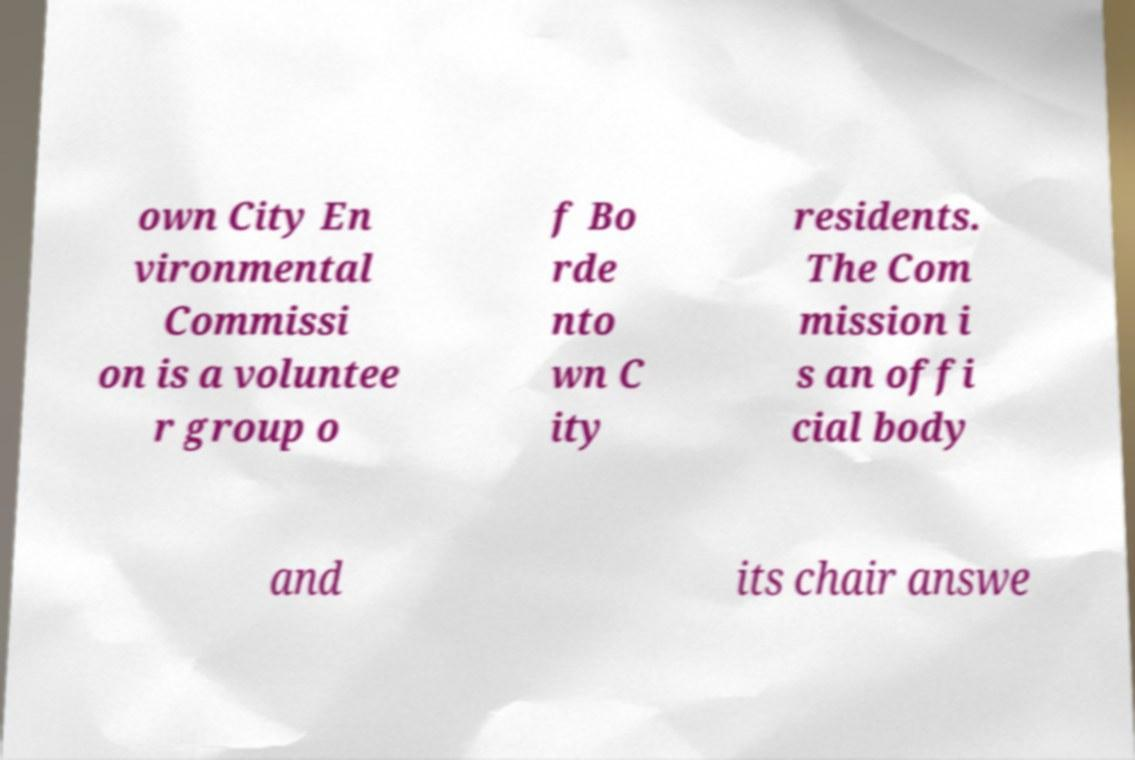There's text embedded in this image that I need extracted. Can you transcribe it verbatim? own City En vironmental Commissi on is a voluntee r group o f Bo rde nto wn C ity residents. The Com mission i s an offi cial body and its chair answe 